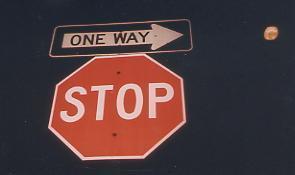How many stop signs are depicted?
Give a very brief answer. 1. 